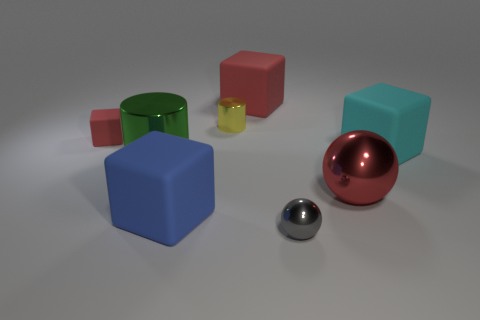How many other objects are the same size as the blue block?
Your answer should be very brief. 4. How many large metal balls have the same color as the small matte object?
Provide a short and direct response. 1. What shape is the object that is both in front of the large red cube and behind the small red matte block?
Your response must be concise. Cylinder. What is the color of the rubber block that is both in front of the tiny matte cube and left of the big cyan rubber cube?
Keep it short and to the point. Blue. Is the number of things to the right of the large sphere greater than the number of balls on the right side of the green cylinder?
Provide a short and direct response. No. What is the color of the large rubber thing that is behind the cyan rubber object?
Offer a terse response. Red. Do the tiny metallic thing in front of the big blue object and the large metallic object that is to the left of the small gray shiny thing have the same shape?
Your answer should be compact. No. Are there any yellow things that have the same size as the green metal thing?
Ensure brevity in your answer.  No. There is a large cube that is on the right side of the big red shiny thing; what is its material?
Provide a succinct answer. Rubber. Is the cyan thing that is in front of the yellow cylinder made of the same material as the tiny cylinder?
Offer a terse response. No. 